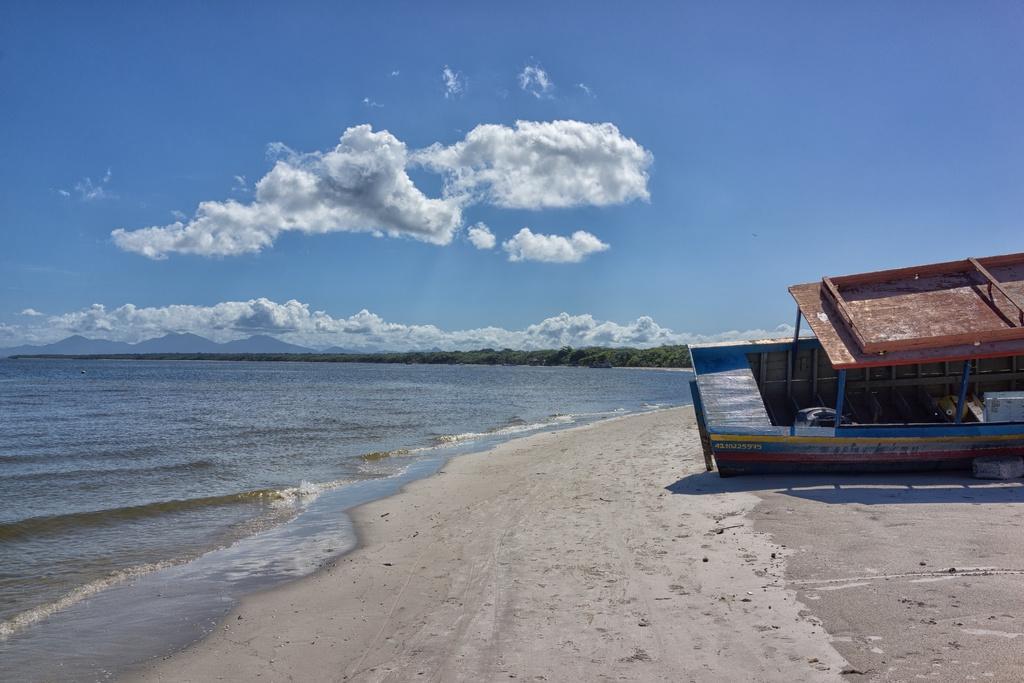Could you give a brief overview of what you see in this image? In this image on the right side there is a boat on the land. On the left side there is an ocean and the sky is cloudy and there are trees in the background. 